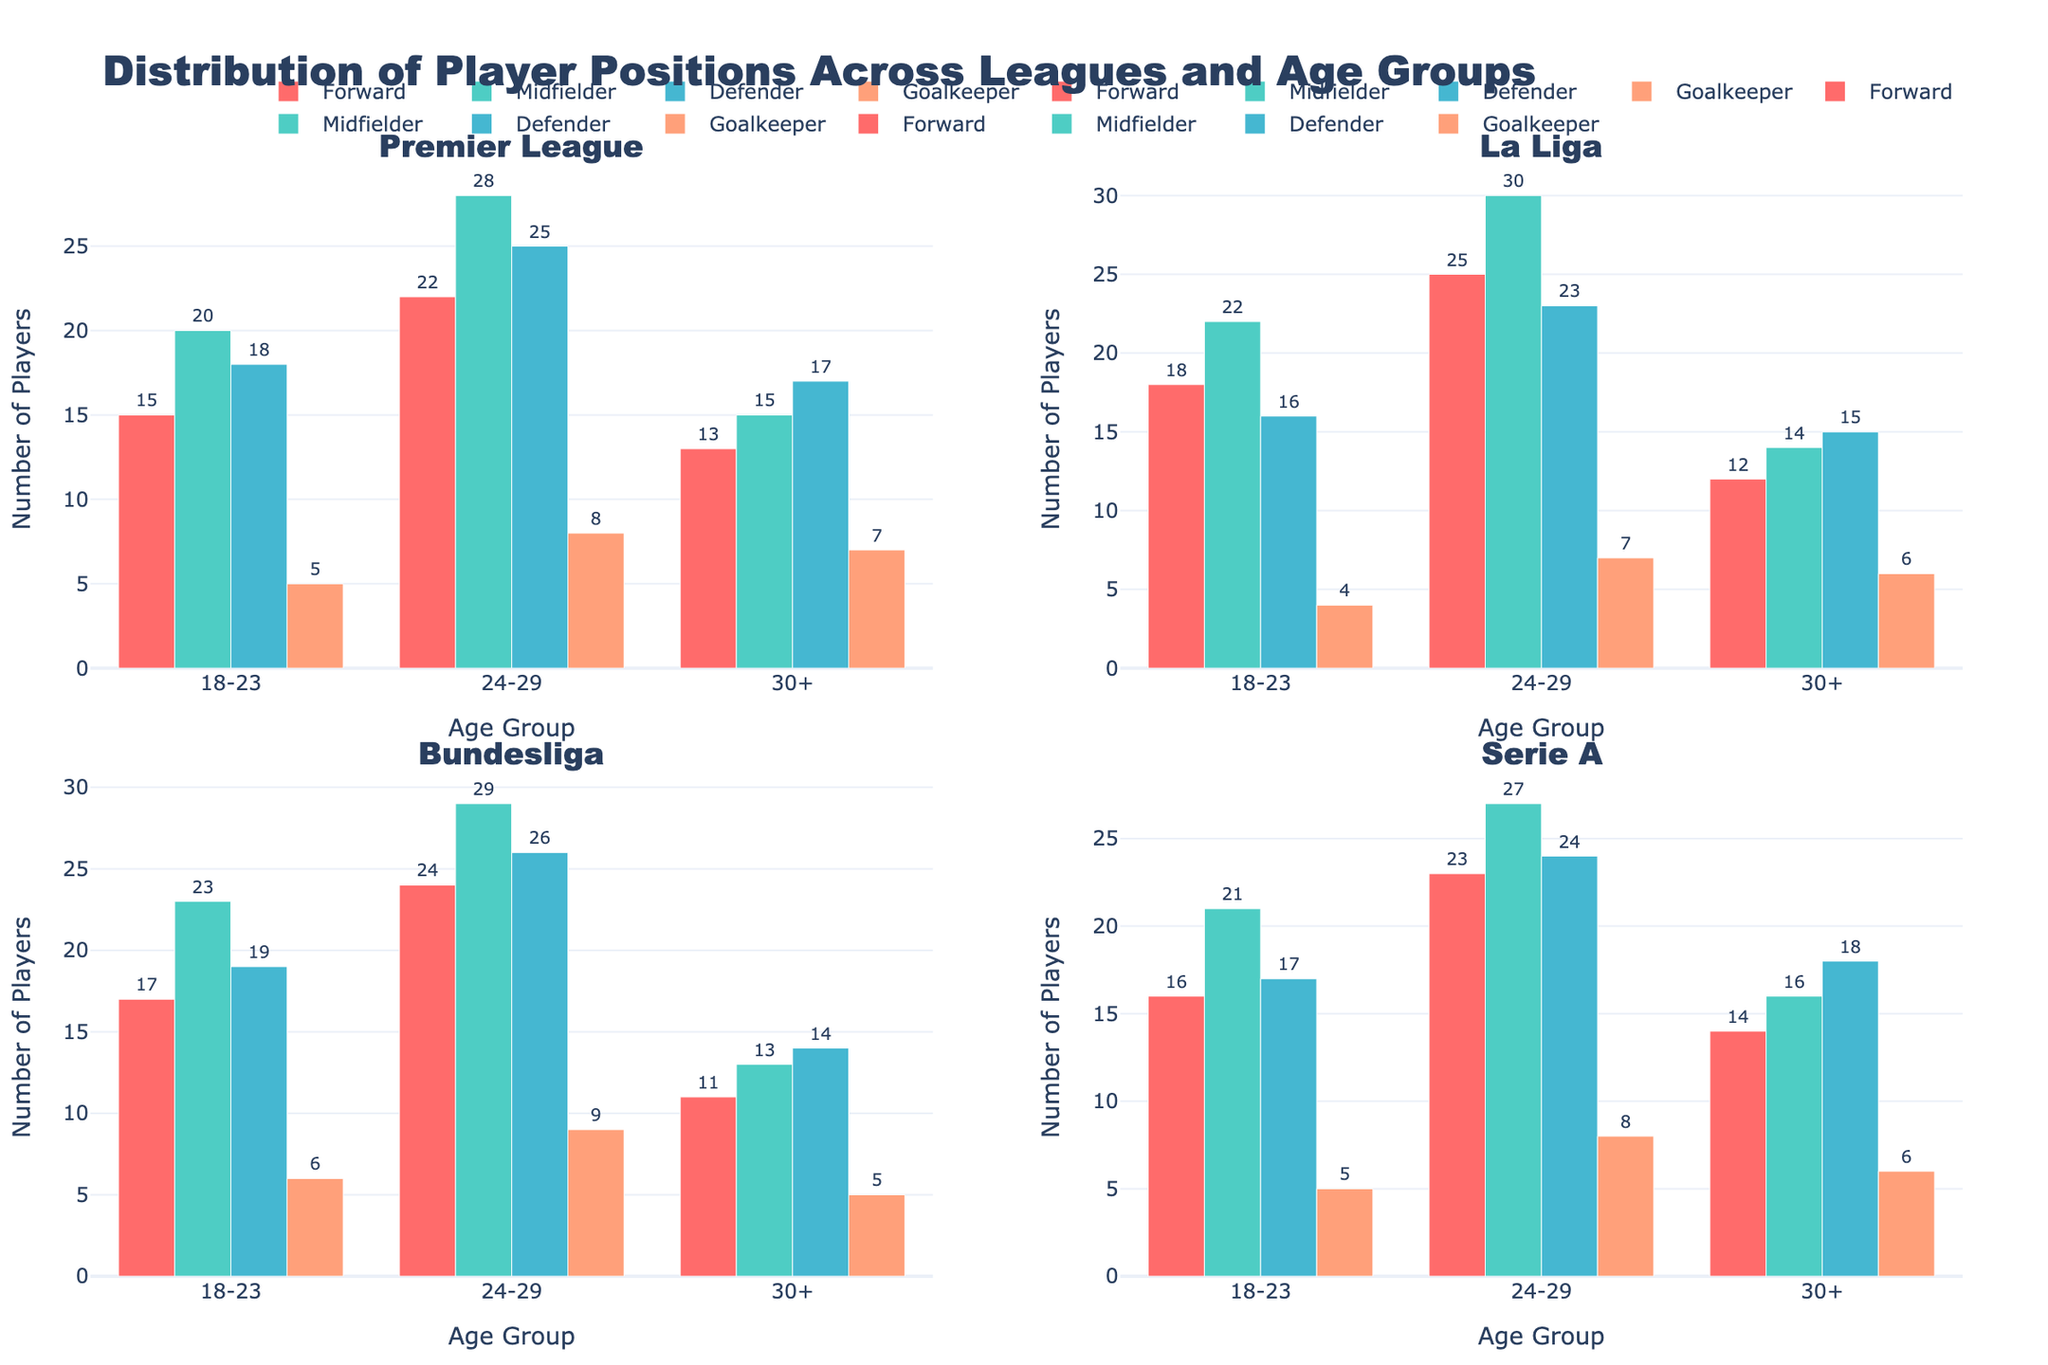What's the title of the figure? The title is usually located at the top of the figure and gives an overview of what the figure is about. In this case, the title is "Distribution of Player Positions Across Leagues and Age Groups," which is displayed prominently at the top.
Answer: Distribution of Player Positions Across Leagues and Age Groups How many leagues are represented in the figure? The figure has subplots for each league, and each subplot has a title with the league name. By counting the number of subplot titles, we can see that there are four leagues: Premier League, La Liga, Bundesliga, and Serie A.
Answer: 4 Which league has the highest number of midfielders in the 24-29 age group? To find this, look at the subplot for each league and compare the height of the bar representing midfielders in the 24-29 age group. The tallest bar is located in La Liga.
Answer: La Liga What is the total number of goalkeepers in all age groups in Bundesliga? We add the number of goalkeepers from each age group within the Bundesliga subplot: 6 (18-23) + 9 (24-29) + 5 (30+).
Answer: 20 Which age group has the least number of defenders in Serie A? Look at the subplot for Serie A and compare the height of the bars representing defenders across all age groups. The smallest bar is in the 18-23 age group.
Answer: 18-23 What is the difference in the number of forwards between the 24-29 and 30+ age groups in the Premier League? In the Premier League subplot, the number of forwards in the 24-29 age group is 22 and in the 30+ age group is 13. The difference is calculated as 22 - 13.
Answer: 9 How do the numbers of forwards in the 18-23 age group compare between Premier League and La Liga? By examining the subplots for both leagues, the number of forwards in the 18-23 age group for Premier League is 15, whereas for La Liga, it is 18.
Answer: La Liga has more forwards Which position has the most players across all age groups in Serie A, and what is the total number of players in that position? By looking at the bars in the Serie A subplot, we see that midfielders have the tallest bars across all age groups. Summing up: 21 (18-23) + 27 (24-29) + 16 (30+).
Answer: Midfielders, 64 